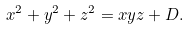<formula> <loc_0><loc_0><loc_500><loc_500>x ^ { 2 } + y ^ { 2 } + z ^ { 2 } = x y z + D .</formula> 